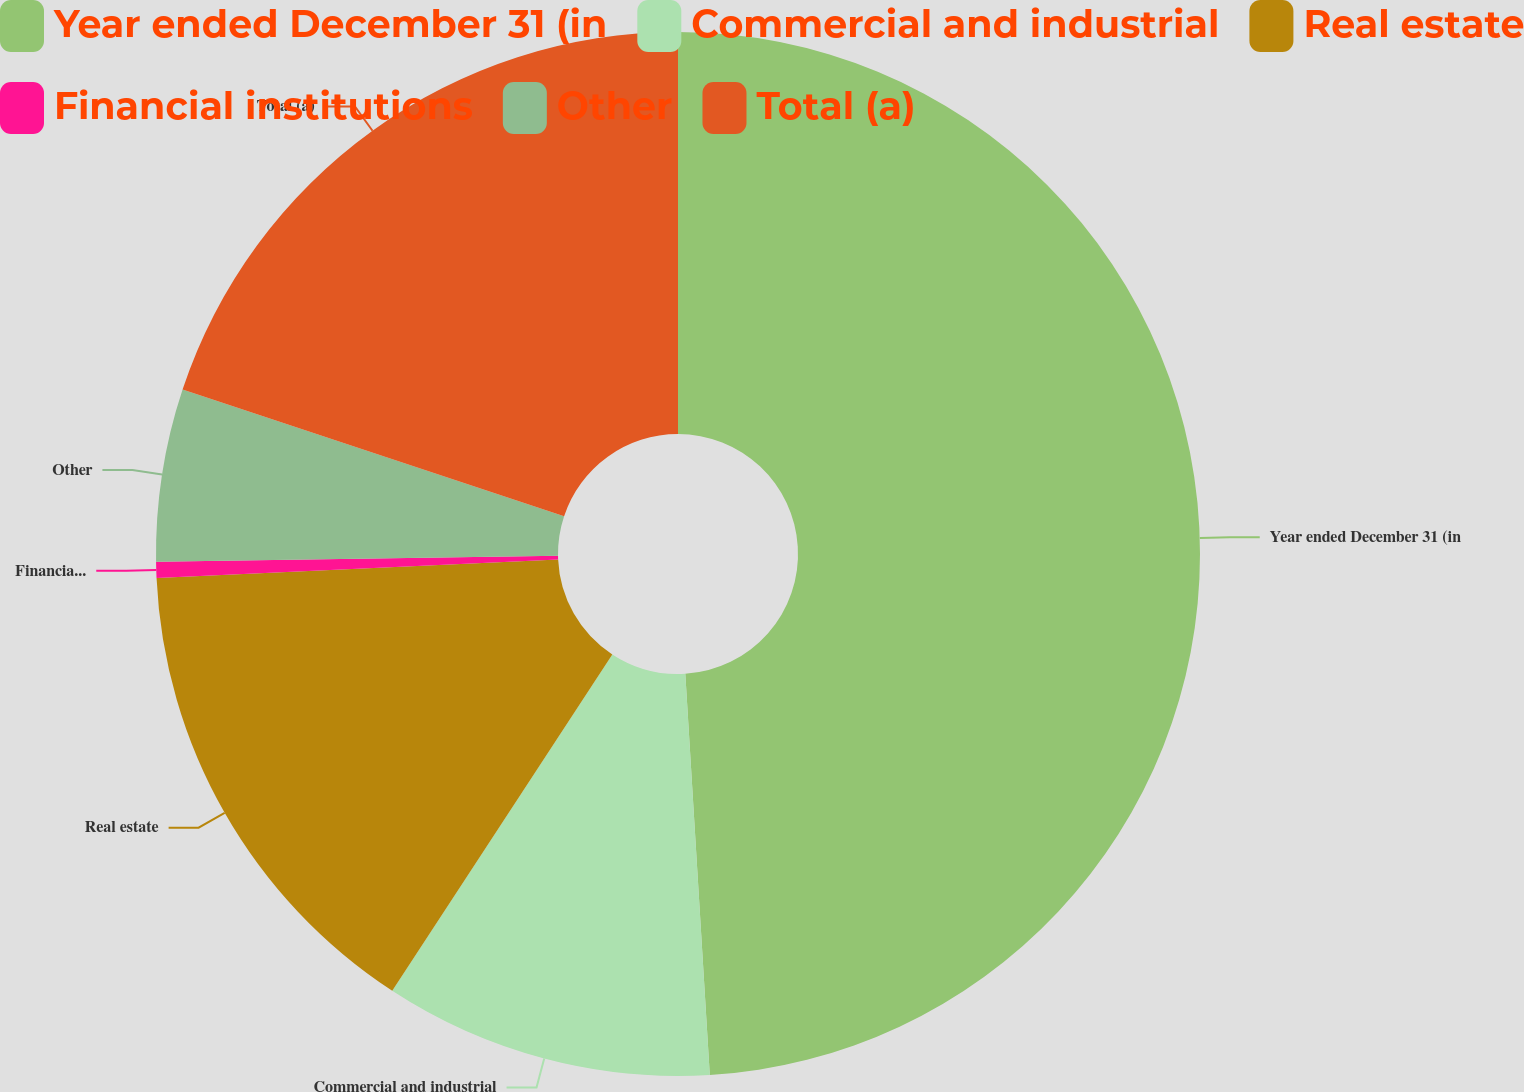<chart> <loc_0><loc_0><loc_500><loc_500><pie_chart><fcel>Year ended December 31 (in<fcel>Commercial and industrial<fcel>Real estate<fcel>Financial institutions<fcel>Other<fcel>Total (a)<nl><fcel>49.03%<fcel>10.19%<fcel>15.05%<fcel>0.49%<fcel>5.34%<fcel>19.9%<nl></chart> 